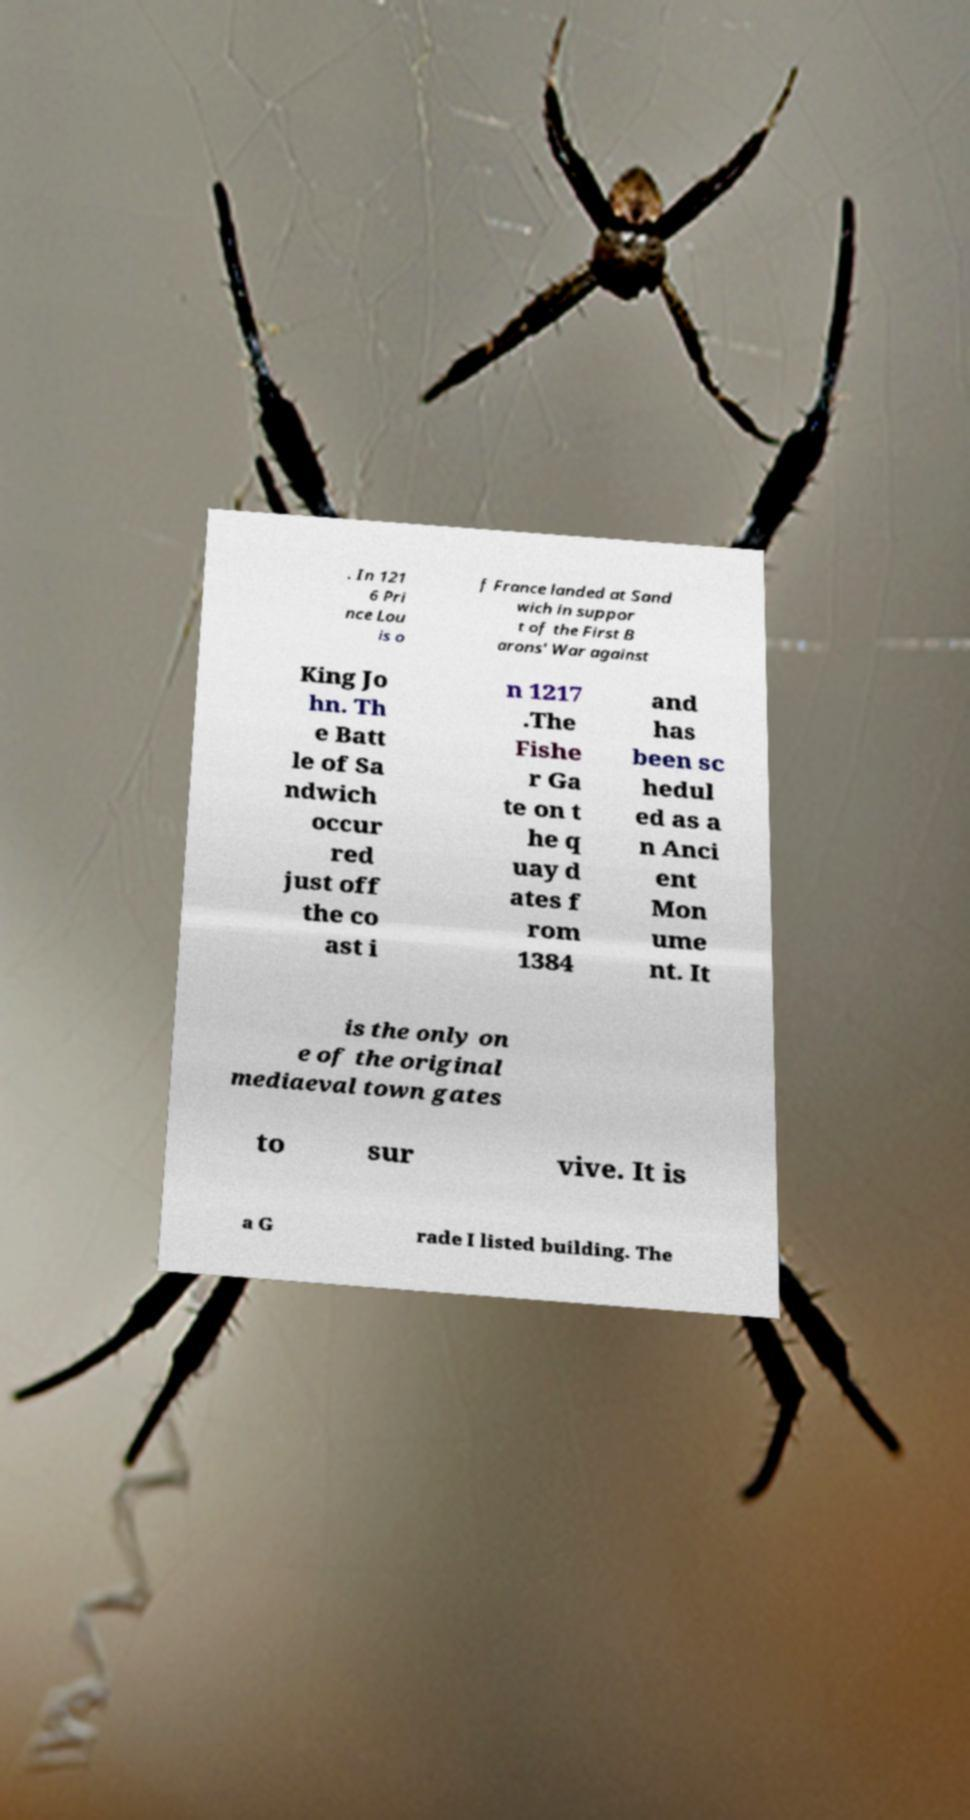What messages or text are displayed in this image? I need them in a readable, typed format. . In 121 6 Pri nce Lou is o f France landed at Sand wich in suppor t of the First B arons' War against King Jo hn. Th e Batt le of Sa ndwich occur red just off the co ast i n 1217 .The Fishe r Ga te on t he q uay d ates f rom 1384 and has been sc hedul ed as a n Anci ent Mon ume nt. It is the only on e of the original mediaeval town gates to sur vive. It is a G rade I listed building. The 